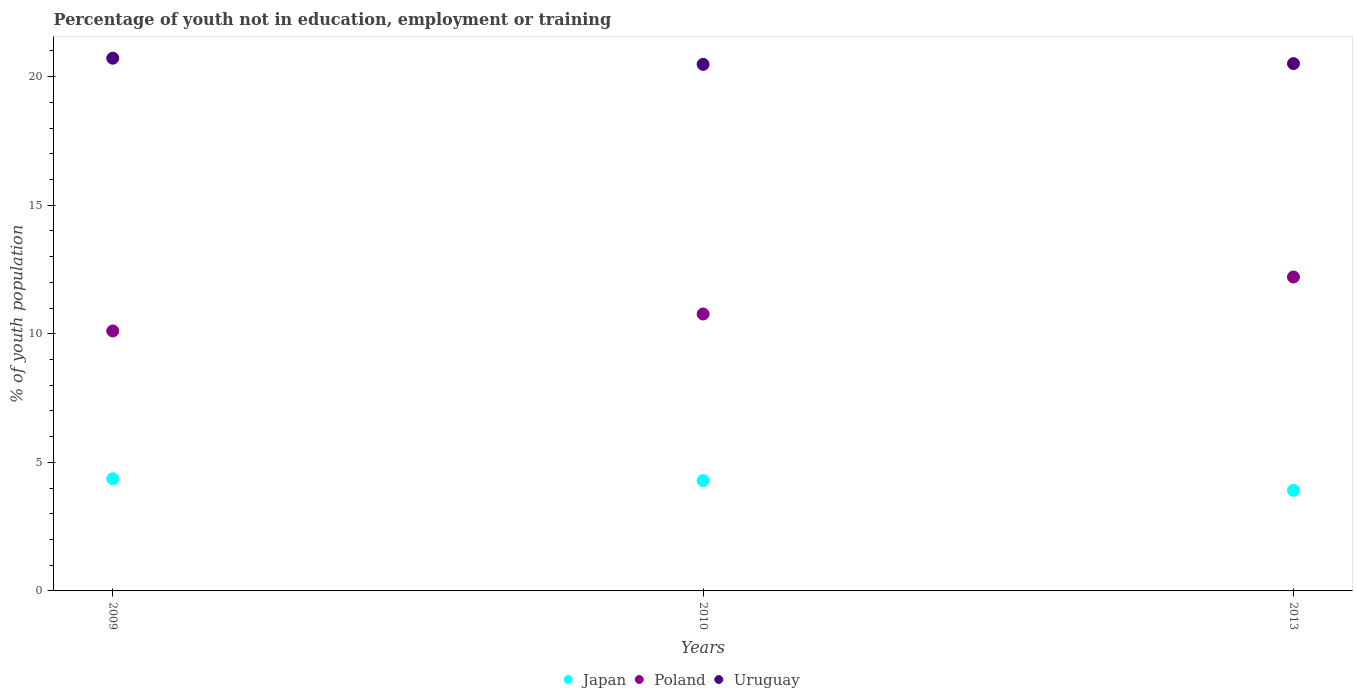Is the number of dotlines equal to the number of legend labels?
Offer a terse response. Yes. What is the percentage of unemployed youth population in in Uruguay in 2010?
Provide a short and direct response. 20.48. Across all years, what is the maximum percentage of unemployed youth population in in Uruguay?
Your response must be concise. 20.72. Across all years, what is the minimum percentage of unemployed youth population in in Uruguay?
Keep it short and to the point. 20.48. In which year was the percentage of unemployed youth population in in Poland maximum?
Your answer should be very brief. 2013. In which year was the percentage of unemployed youth population in in Poland minimum?
Ensure brevity in your answer.  2009. What is the total percentage of unemployed youth population in in Japan in the graph?
Offer a very short reply. 12.56. What is the difference between the percentage of unemployed youth population in in Japan in 2009 and that in 2013?
Ensure brevity in your answer.  0.45. What is the difference between the percentage of unemployed youth population in in Poland in 2009 and the percentage of unemployed youth population in in Uruguay in 2010?
Your response must be concise. -10.37. What is the average percentage of unemployed youth population in in Japan per year?
Provide a succinct answer. 4.19. In the year 2010, what is the difference between the percentage of unemployed youth population in in Japan and percentage of unemployed youth population in in Uruguay?
Offer a very short reply. -16.19. In how many years, is the percentage of unemployed youth population in in Poland greater than 12 %?
Provide a succinct answer. 1. What is the ratio of the percentage of unemployed youth population in in Uruguay in 2009 to that in 2013?
Your answer should be compact. 1.01. What is the difference between the highest and the second highest percentage of unemployed youth population in in Poland?
Your response must be concise. 1.44. What is the difference between the highest and the lowest percentage of unemployed youth population in in Poland?
Your answer should be compact. 2.1. Is the sum of the percentage of unemployed youth population in in Uruguay in 2009 and 2013 greater than the maximum percentage of unemployed youth population in in Poland across all years?
Offer a terse response. Yes. Is it the case that in every year, the sum of the percentage of unemployed youth population in in Poland and percentage of unemployed youth population in in Uruguay  is greater than the percentage of unemployed youth population in in Japan?
Give a very brief answer. Yes. Does the percentage of unemployed youth population in in Japan monotonically increase over the years?
Offer a very short reply. No. Is the percentage of unemployed youth population in in Uruguay strictly less than the percentage of unemployed youth population in in Japan over the years?
Give a very brief answer. No. How many years are there in the graph?
Ensure brevity in your answer.  3. What is the difference between two consecutive major ticks on the Y-axis?
Ensure brevity in your answer.  5. Are the values on the major ticks of Y-axis written in scientific E-notation?
Your response must be concise. No. Does the graph contain any zero values?
Give a very brief answer. No. How many legend labels are there?
Your response must be concise. 3. What is the title of the graph?
Offer a very short reply. Percentage of youth not in education, employment or training. Does "Micronesia" appear as one of the legend labels in the graph?
Provide a succinct answer. No. What is the label or title of the X-axis?
Your answer should be very brief. Years. What is the label or title of the Y-axis?
Offer a very short reply. % of youth population. What is the % of youth population in Japan in 2009?
Your answer should be very brief. 4.36. What is the % of youth population in Poland in 2009?
Offer a very short reply. 10.11. What is the % of youth population in Uruguay in 2009?
Give a very brief answer. 20.72. What is the % of youth population of Japan in 2010?
Make the answer very short. 4.29. What is the % of youth population of Poland in 2010?
Offer a terse response. 10.77. What is the % of youth population in Uruguay in 2010?
Your response must be concise. 20.48. What is the % of youth population of Japan in 2013?
Provide a short and direct response. 3.91. What is the % of youth population in Poland in 2013?
Your answer should be very brief. 12.21. What is the % of youth population of Uruguay in 2013?
Your response must be concise. 20.51. Across all years, what is the maximum % of youth population in Japan?
Make the answer very short. 4.36. Across all years, what is the maximum % of youth population in Poland?
Your response must be concise. 12.21. Across all years, what is the maximum % of youth population of Uruguay?
Offer a terse response. 20.72. Across all years, what is the minimum % of youth population of Japan?
Your answer should be very brief. 3.91. Across all years, what is the minimum % of youth population in Poland?
Provide a short and direct response. 10.11. Across all years, what is the minimum % of youth population of Uruguay?
Offer a very short reply. 20.48. What is the total % of youth population in Japan in the graph?
Your answer should be compact. 12.56. What is the total % of youth population of Poland in the graph?
Keep it short and to the point. 33.09. What is the total % of youth population of Uruguay in the graph?
Offer a terse response. 61.71. What is the difference between the % of youth population in Japan in 2009 and that in 2010?
Make the answer very short. 0.07. What is the difference between the % of youth population in Poland in 2009 and that in 2010?
Make the answer very short. -0.66. What is the difference between the % of youth population in Uruguay in 2009 and that in 2010?
Offer a terse response. 0.24. What is the difference between the % of youth population of Japan in 2009 and that in 2013?
Provide a short and direct response. 0.45. What is the difference between the % of youth population in Uruguay in 2009 and that in 2013?
Your response must be concise. 0.21. What is the difference between the % of youth population in Japan in 2010 and that in 2013?
Give a very brief answer. 0.38. What is the difference between the % of youth population of Poland in 2010 and that in 2013?
Provide a short and direct response. -1.44. What is the difference between the % of youth population in Uruguay in 2010 and that in 2013?
Ensure brevity in your answer.  -0.03. What is the difference between the % of youth population in Japan in 2009 and the % of youth population in Poland in 2010?
Offer a very short reply. -6.41. What is the difference between the % of youth population of Japan in 2009 and the % of youth population of Uruguay in 2010?
Your answer should be compact. -16.12. What is the difference between the % of youth population of Poland in 2009 and the % of youth population of Uruguay in 2010?
Make the answer very short. -10.37. What is the difference between the % of youth population in Japan in 2009 and the % of youth population in Poland in 2013?
Ensure brevity in your answer.  -7.85. What is the difference between the % of youth population in Japan in 2009 and the % of youth population in Uruguay in 2013?
Give a very brief answer. -16.15. What is the difference between the % of youth population in Japan in 2010 and the % of youth population in Poland in 2013?
Your answer should be very brief. -7.92. What is the difference between the % of youth population in Japan in 2010 and the % of youth population in Uruguay in 2013?
Your response must be concise. -16.22. What is the difference between the % of youth population in Poland in 2010 and the % of youth population in Uruguay in 2013?
Give a very brief answer. -9.74. What is the average % of youth population of Japan per year?
Offer a very short reply. 4.19. What is the average % of youth population of Poland per year?
Keep it short and to the point. 11.03. What is the average % of youth population in Uruguay per year?
Make the answer very short. 20.57. In the year 2009, what is the difference between the % of youth population of Japan and % of youth population of Poland?
Your response must be concise. -5.75. In the year 2009, what is the difference between the % of youth population in Japan and % of youth population in Uruguay?
Make the answer very short. -16.36. In the year 2009, what is the difference between the % of youth population of Poland and % of youth population of Uruguay?
Keep it short and to the point. -10.61. In the year 2010, what is the difference between the % of youth population in Japan and % of youth population in Poland?
Your answer should be very brief. -6.48. In the year 2010, what is the difference between the % of youth population of Japan and % of youth population of Uruguay?
Provide a succinct answer. -16.19. In the year 2010, what is the difference between the % of youth population of Poland and % of youth population of Uruguay?
Your answer should be very brief. -9.71. In the year 2013, what is the difference between the % of youth population in Japan and % of youth population in Poland?
Make the answer very short. -8.3. In the year 2013, what is the difference between the % of youth population in Japan and % of youth population in Uruguay?
Keep it short and to the point. -16.6. What is the ratio of the % of youth population of Japan in 2009 to that in 2010?
Ensure brevity in your answer.  1.02. What is the ratio of the % of youth population in Poland in 2009 to that in 2010?
Your answer should be compact. 0.94. What is the ratio of the % of youth population of Uruguay in 2009 to that in 2010?
Offer a very short reply. 1.01. What is the ratio of the % of youth population in Japan in 2009 to that in 2013?
Offer a very short reply. 1.12. What is the ratio of the % of youth population of Poland in 2009 to that in 2013?
Offer a very short reply. 0.83. What is the ratio of the % of youth population of Uruguay in 2009 to that in 2013?
Your answer should be compact. 1.01. What is the ratio of the % of youth population of Japan in 2010 to that in 2013?
Make the answer very short. 1.1. What is the ratio of the % of youth population in Poland in 2010 to that in 2013?
Provide a short and direct response. 0.88. What is the difference between the highest and the second highest % of youth population in Japan?
Ensure brevity in your answer.  0.07. What is the difference between the highest and the second highest % of youth population in Poland?
Your response must be concise. 1.44. What is the difference between the highest and the second highest % of youth population of Uruguay?
Offer a terse response. 0.21. What is the difference between the highest and the lowest % of youth population in Japan?
Your answer should be compact. 0.45. What is the difference between the highest and the lowest % of youth population of Uruguay?
Offer a very short reply. 0.24. 